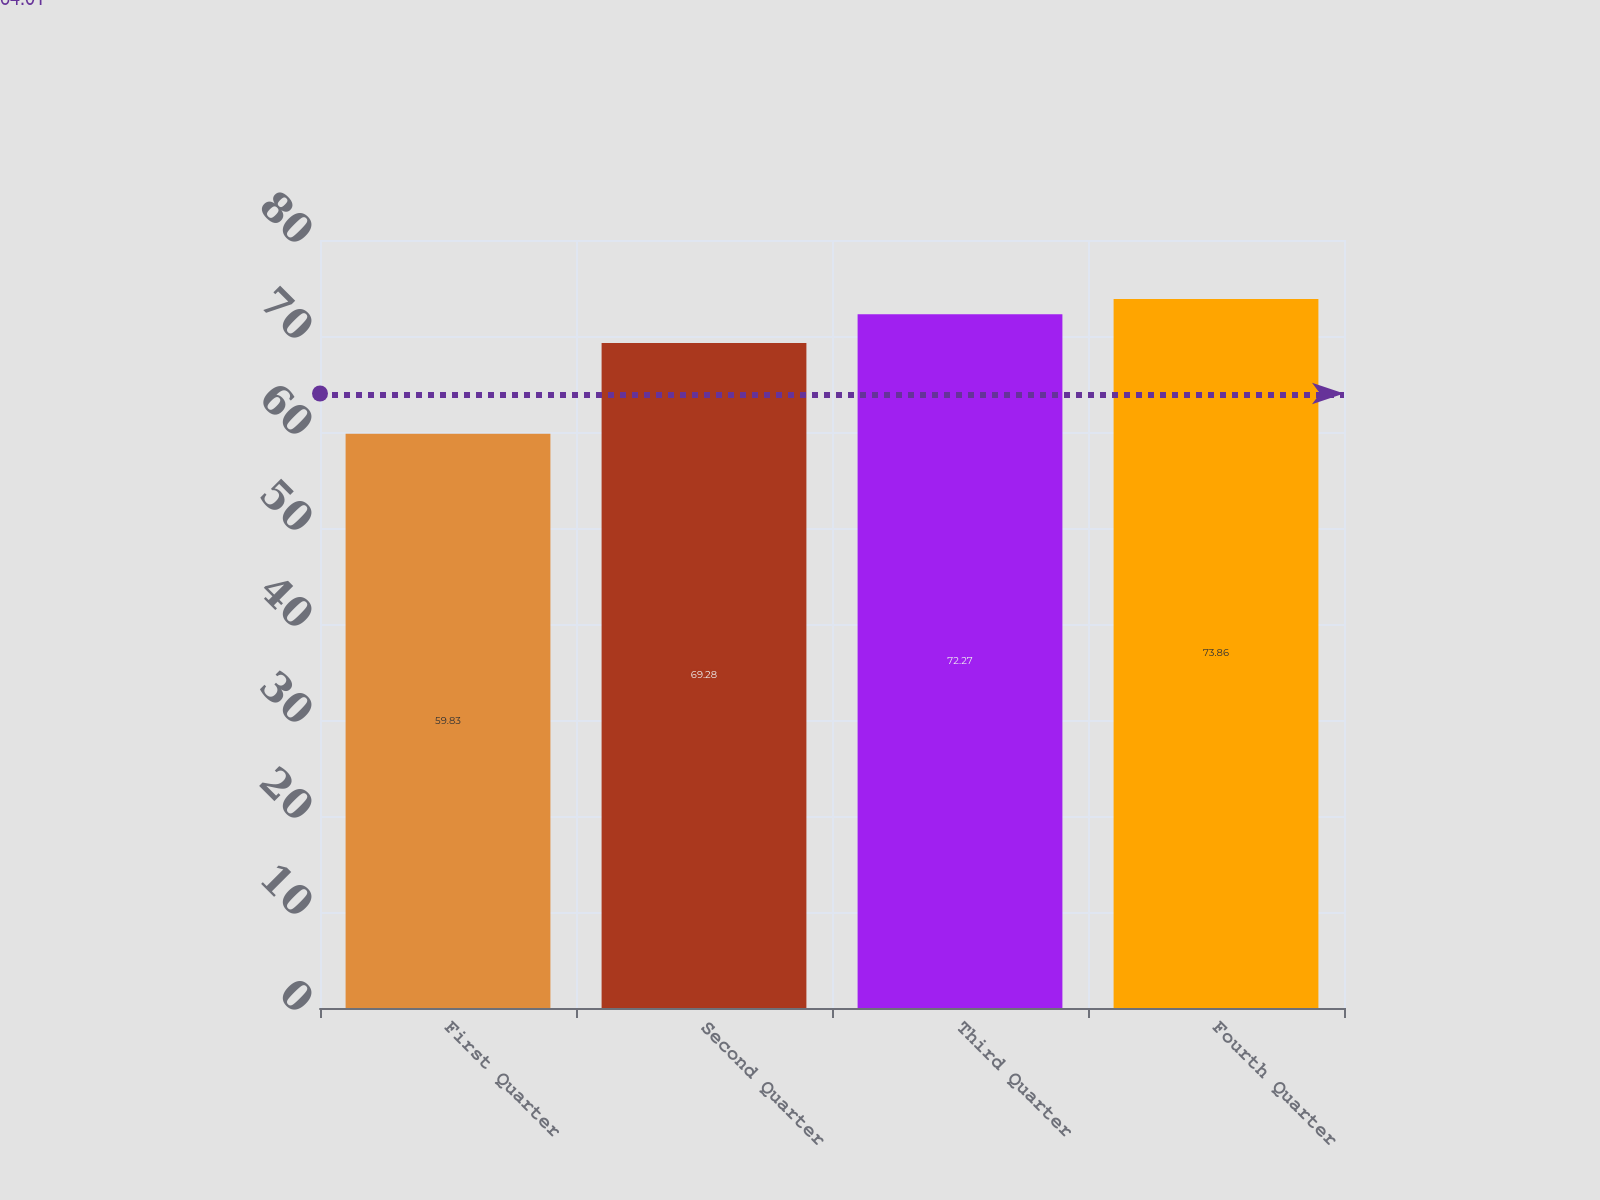<chart> <loc_0><loc_0><loc_500><loc_500><bar_chart><fcel>First Quarter<fcel>Second Quarter<fcel>Third Quarter<fcel>Fourth Quarter<nl><fcel>59.83<fcel>69.28<fcel>72.27<fcel>73.86<nl></chart> 